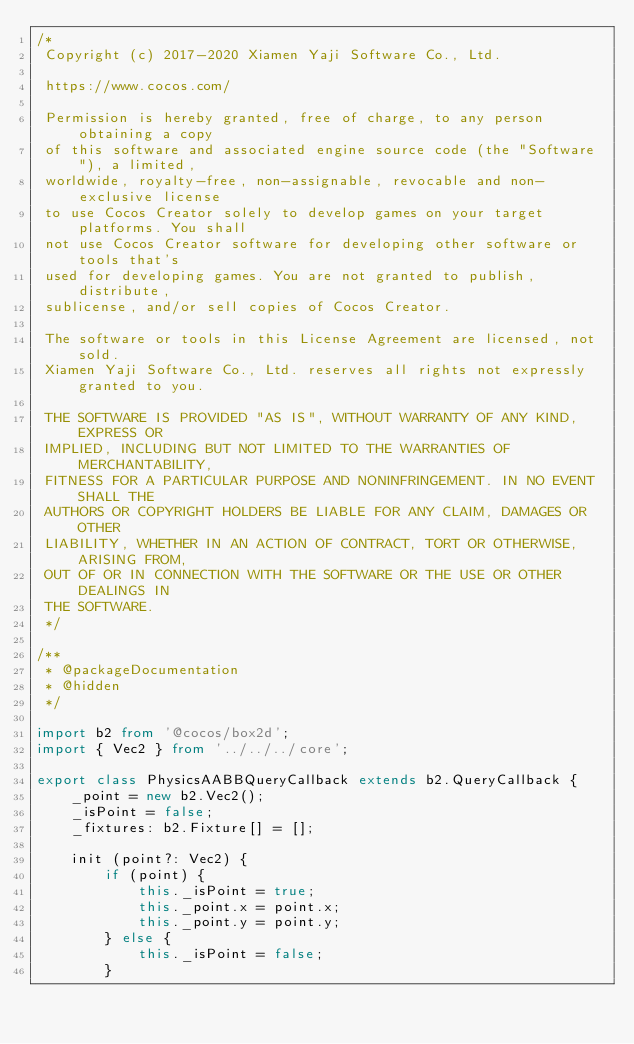Convert code to text. <code><loc_0><loc_0><loc_500><loc_500><_TypeScript_>/*
 Copyright (c) 2017-2020 Xiamen Yaji Software Co., Ltd.

 https://www.cocos.com/

 Permission is hereby granted, free of charge, to any person obtaining a copy
 of this software and associated engine source code (the "Software"), a limited,
 worldwide, royalty-free, non-assignable, revocable and non-exclusive license
 to use Cocos Creator solely to develop games on your target platforms. You shall
 not use Cocos Creator software for developing other software or tools that's
 used for developing games. You are not granted to publish, distribute,
 sublicense, and/or sell copies of Cocos Creator.

 The software or tools in this License Agreement are licensed, not sold.
 Xiamen Yaji Software Co., Ltd. reserves all rights not expressly granted to you.

 THE SOFTWARE IS PROVIDED "AS IS", WITHOUT WARRANTY OF ANY KIND, EXPRESS OR
 IMPLIED, INCLUDING BUT NOT LIMITED TO THE WARRANTIES OF MERCHANTABILITY,
 FITNESS FOR A PARTICULAR PURPOSE AND NONINFRINGEMENT. IN NO EVENT SHALL THE
 AUTHORS OR COPYRIGHT HOLDERS BE LIABLE FOR ANY CLAIM, DAMAGES OR OTHER
 LIABILITY, WHETHER IN AN ACTION OF CONTRACT, TORT OR OTHERWISE, ARISING FROM,
 OUT OF OR IN CONNECTION WITH THE SOFTWARE OR THE USE OR OTHER DEALINGS IN
 THE SOFTWARE.
 */

/**
 * @packageDocumentation
 * @hidden
 */

import b2 from '@cocos/box2d';
import { Vec2 } from '../../../core';

export class PhysicsAABBQueryCallback extends b2.QueryCallback {
    _point = new b2.Vec2();
    _isPoint = false;
    _fixtures: b2.Fixture[] = [];

    init (point?: Vec2) {
        if (point) {
            this._isPoint = true;
            this._point.x = point.x;
            this._point.y = point.y;
        } else {
            this._isPoint = false;
        }
</code> 